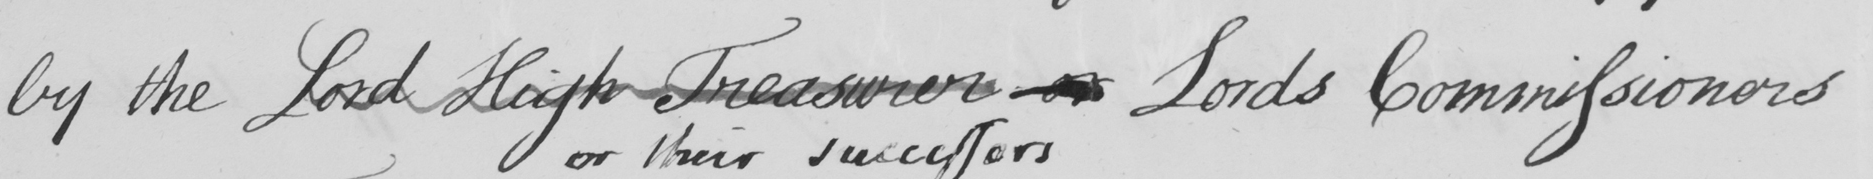Please transcribe the handwritten text in this image. by the Lord High Treasurer or Lords Commissioners 